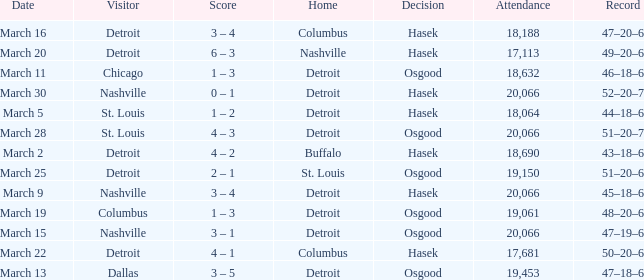What was the decision of the Red Wings game when they had a record of 45–18–6? Hasek. 